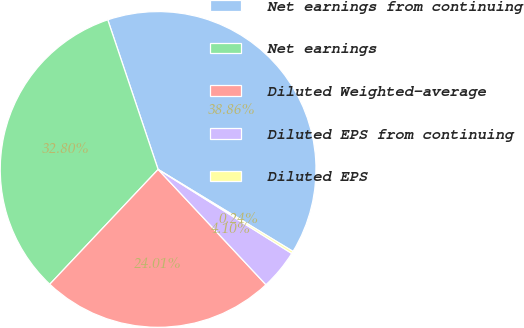Convert chart. <chart><loc_0><loc_0><loc_500><loc_500><pie_chart><fcel>Net earnings from continuing<fcel>Net earnings<fcel>Diluted Weighted-average<fcel>Diluted EPS from continuing<fcel>Diluted EPS<nl><fcel>38.86%<fcel>32.8%<fcel>24.01%<fcel>4.1%<fcel>0.24%<nl></chart> 